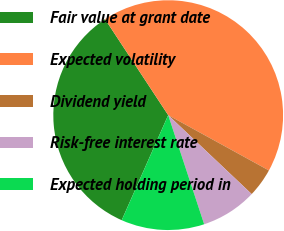Convert chart to OTSL. <chart><loc_0><loc_0><loc_500><loc_500><pie_chart><fcel>Fair value at grant date<fcel>Expected volatility<fcel>Dividend yield<fcel>Risk-free interest rate<fcel>Expected holding period in<nl><fcel>34.11%<fcel>42.26%<fcel>4.06%<fcel>7.88%<fcel>11.7%<nl></chart> 